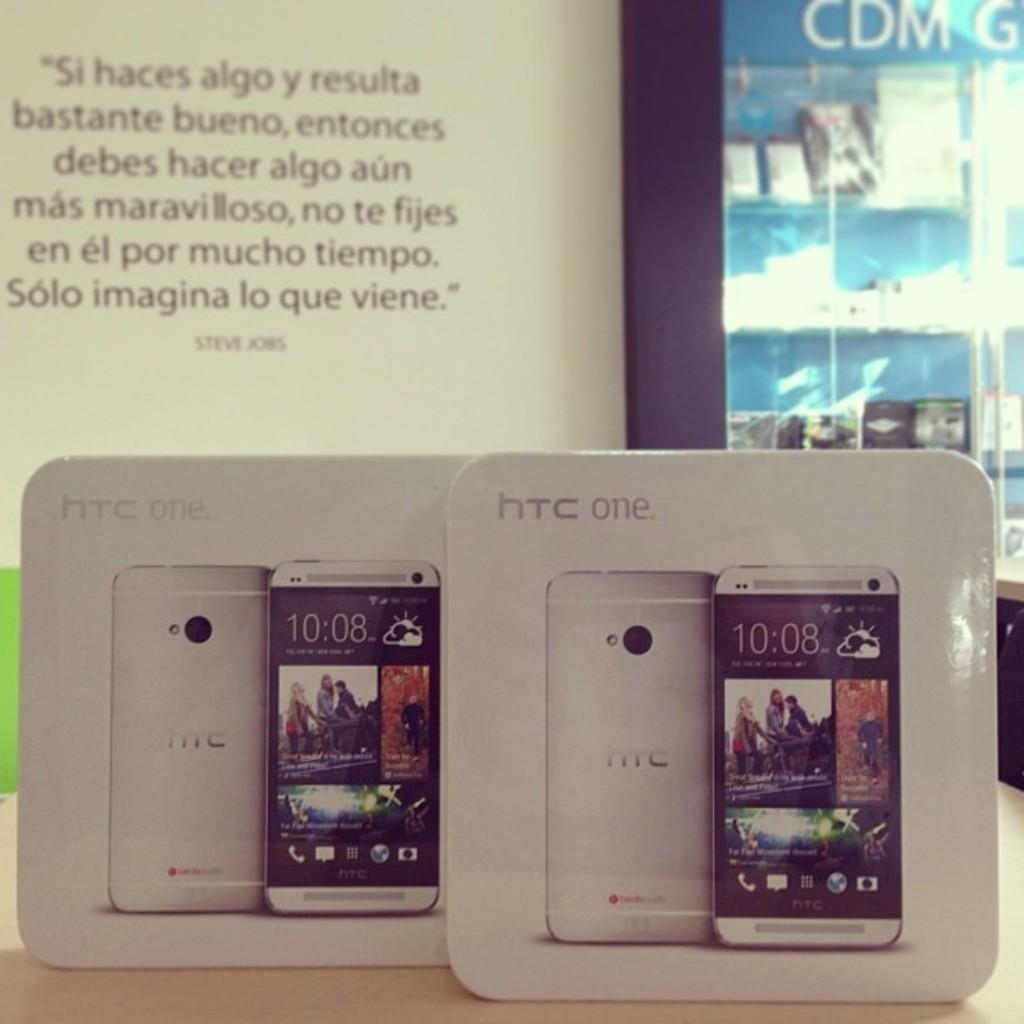<image>
Write a terse but informative summary of the picture. two HTC one phones are displayed in their boxes 